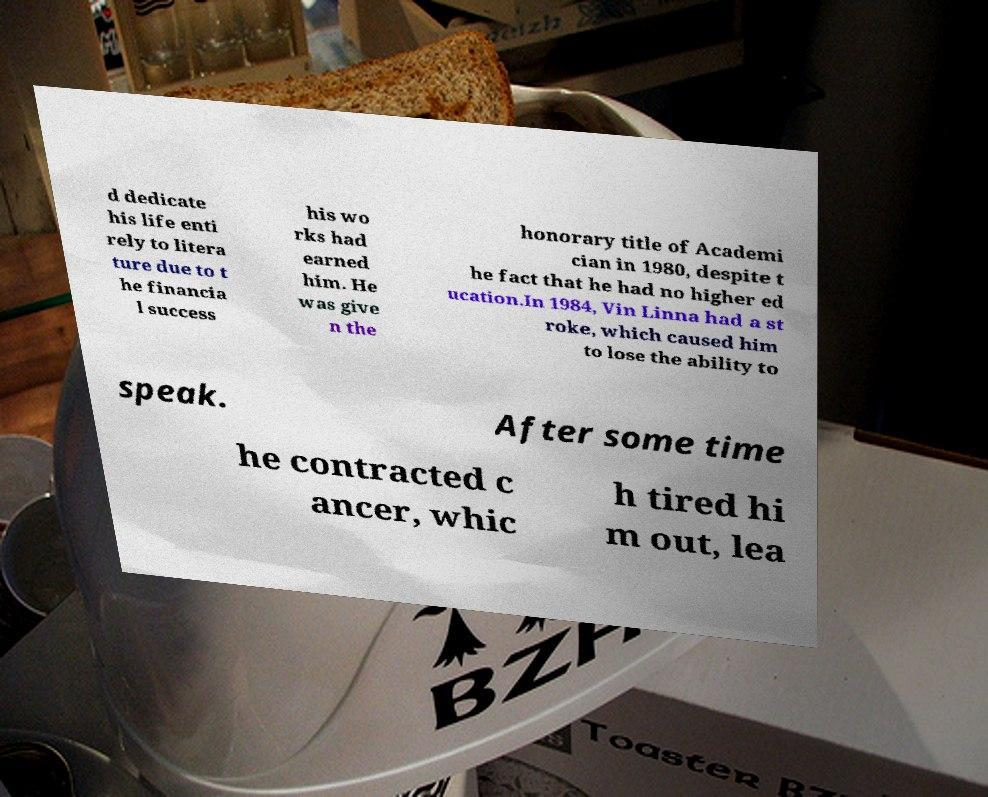Please identify and transcribe the text found in this image. d dedicate his life enti rely to litera ture due to t he financia l success his wo rks had earned him. He was give n the honorary title of Academi cian in 1980, despite t he fact that he had no higher ed ucation.In 1984, Vin Linna had a st roke, which caused him to lose the ability to speak. After some time he contracted c ancer, whic h tired hi m out, lea 